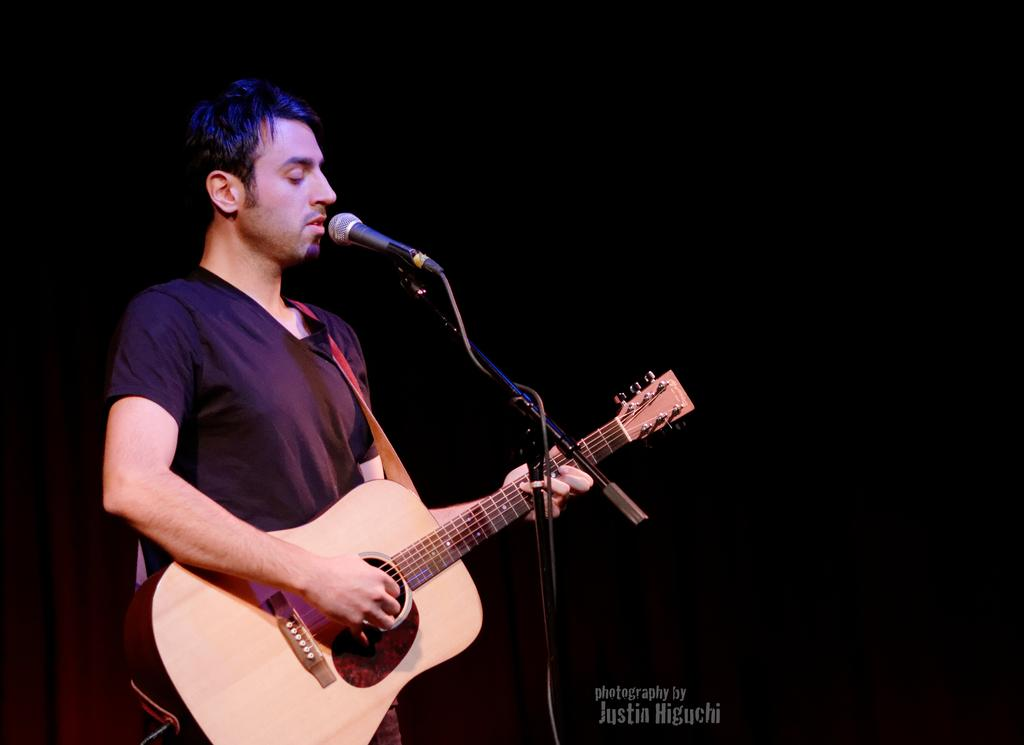Who is the main subject in the image? There is a man in the image. What is the man doing in the image? The man is standing and holding a guitar. What is the man standing in front of? The man is standing in front of a mic. What is the color of the background in the image? The background of the image is black. How many bulbs are visible in the image? There are no bulbs visible in the image. What type of flight is the man taking in the image? There is no flight present in the image; the man is standing in front of a mic with a guitar. 